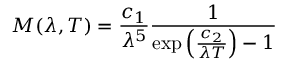<formula> <loc_0><loc_0><loc_500><loc_500>M ( \lambda , T ) = { \frac { c _ { 1 } } { \lambda ^ { 5 } } } { \frac { 1 } { \exp \left ( { \frac { c _ { 2 } } { { \lambda } T } } \right ) - 1 } }</formula> 